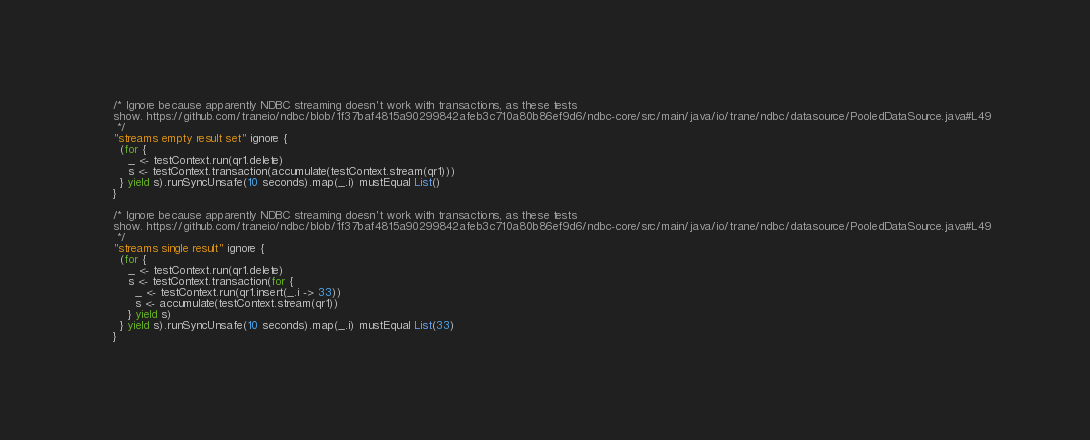Convert code to text. <code><loc_0><loc_0><loc_500><loc_500><_Scala_>    /* Ignore because apparently NDBC streaming doesn't work with transactions, as these tests
    show. https://github.com/traneio/ndbc/blob/1f37baf4815a90299842afeb3c710a80b86ef9d6/ndbc-core/src/main/java/io/trane/ndbc/datasource/PooledDataSource.java#L49
     */
    "streams empty result set" ignore {
      (for {
        _ <- testContext.run(qr1.delete)
        s <- testContext.transaction(accumulate(testContext.stream(qr1)))
      } yield s).runSyncUnsafe(10 seconds).map(_.i) mustEqual List()
    }

    /* Ignore because apparently NDBC streaming doesn't work with transactions, as these tests
    show. https://github.com/traneio/ndbc/blob/1f37baf4815a90299842afeb3c710a80b86ef9d6/ndbc-core/src/main/java/io/trane/ndbc/datasource/PooledDataSource.java#L49
     */
    "streams single result" ignore {
      (for {
        _ <- testContext.run(qr1.delete)
        s <- testContext.transaction(for {
          _ <- testContext.run(qr1.insert(_.i -> 33))
          s <- accumulate(testContext.stream(qr1))
        } yield s)
      } yield s).runSyncUnsafe(10 seconds).map(_.i) mustEqual List(33)
    }
</code> 